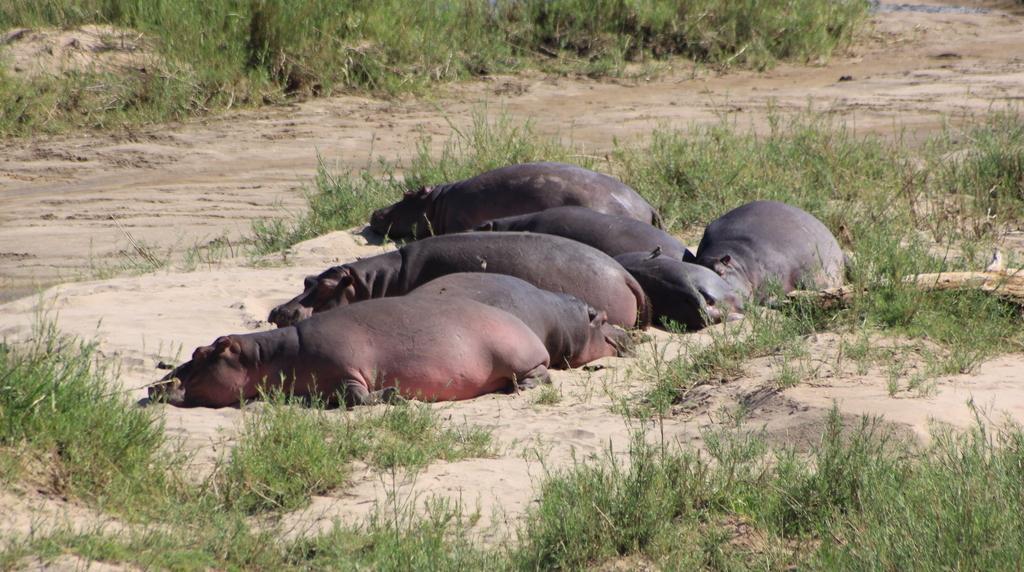Please provide a concise description of this image. In the center of the image some hippopotamus are lying on the ground. At the top of the image grass is there. In the middle of the image soil is present. 